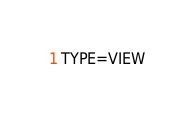<code> <loc_0><loc_0><loc_500><loc_500><_VisualBasic_>TYPE=VIEW</code> 